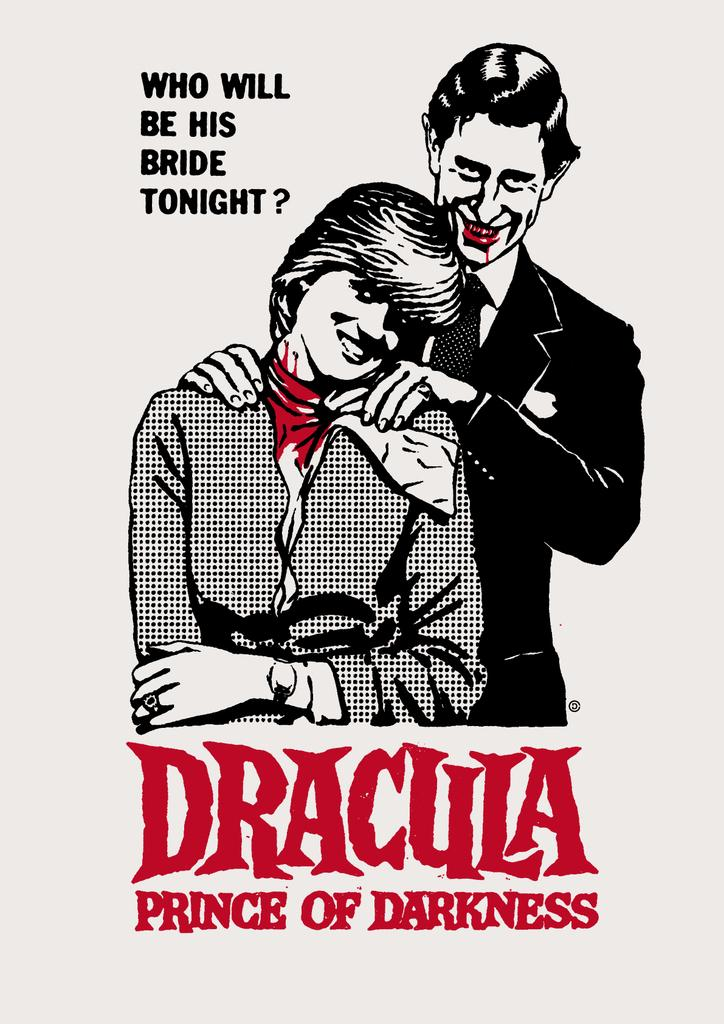What is the main object in the image? There is a paper in the image. What is depicted on the paper? There are two persons depicted on the paper. What else can be seen on the paper? There is writing on the paper. How many geese are present in the image? There are no geese present in the image; it only features a paper with two persons and writing. What type of truck can be seen in the image? There is no truck present in the image. 